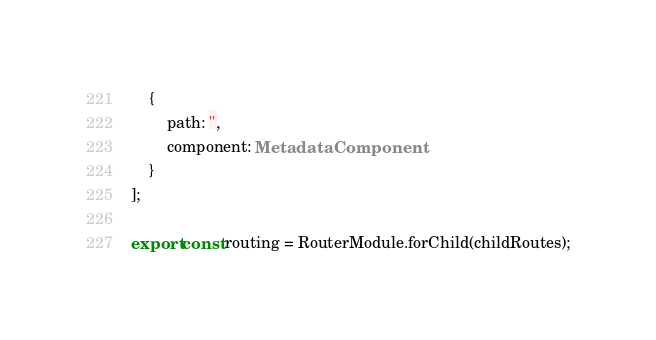<code> <loc_0><loc_0><loc_500><loc_500><_TypeScript_>    {
        path: '',
        component: MetadataComponent
    }
];

export const routing = RouterModule.forChild(childRoutes);
</code> 